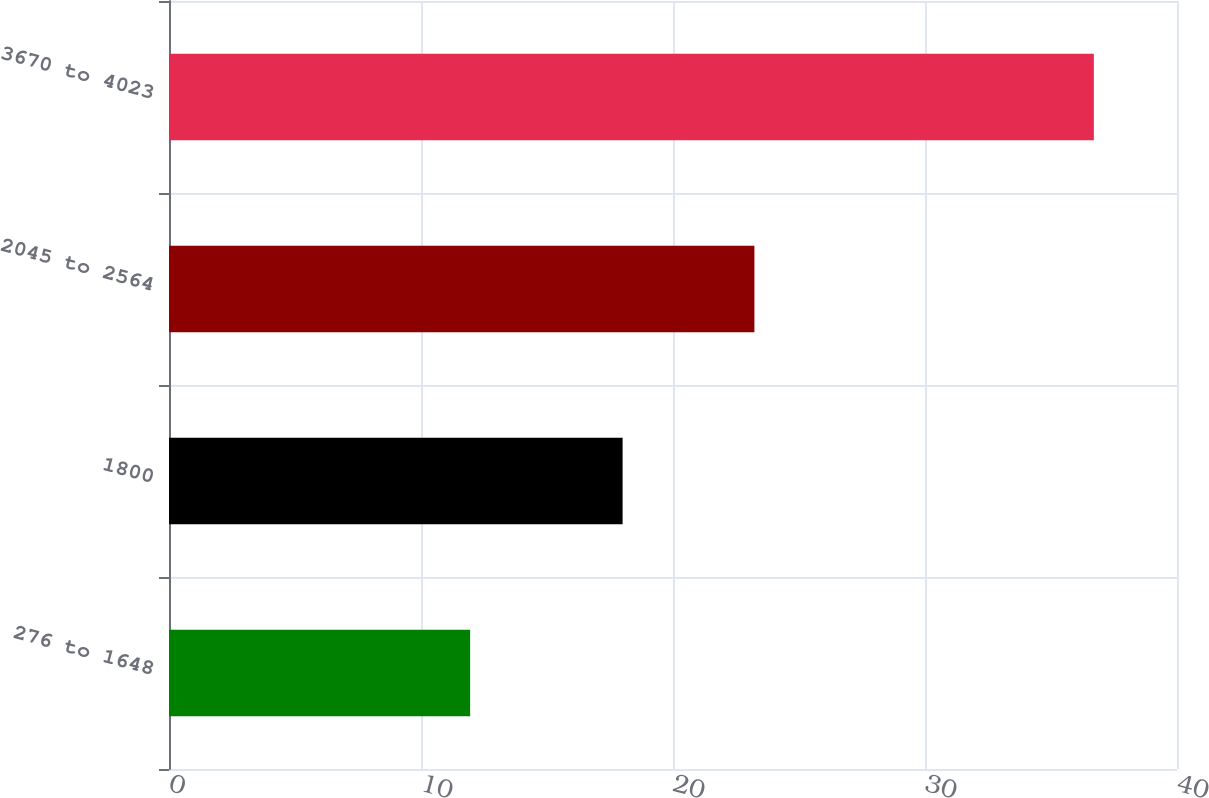<chart> <loc_0><loc_0><loc_500><loc_500><bar_chart><fcel>276 to 1648<fcel>1800<fcel>2045 to 2564<fcel>3670 to 4023<nl><fcel>11.95<fcel>18<fcel>23.23<fcel>36.7<nl></chart> 